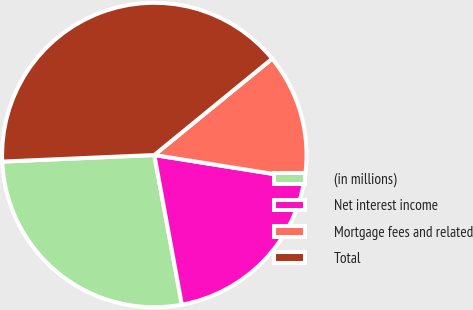<chart> <loc_0><loc_0><loc_500><loc_500><pie_chart><fcel>(in millions)<fcel>Net interest income<fcel>Mortgage fees and related<fcel>Total<nl><fcel>27.2%<fcel>19.59%<fcel>13.42%<fcel>39.78%<nl></chart> 